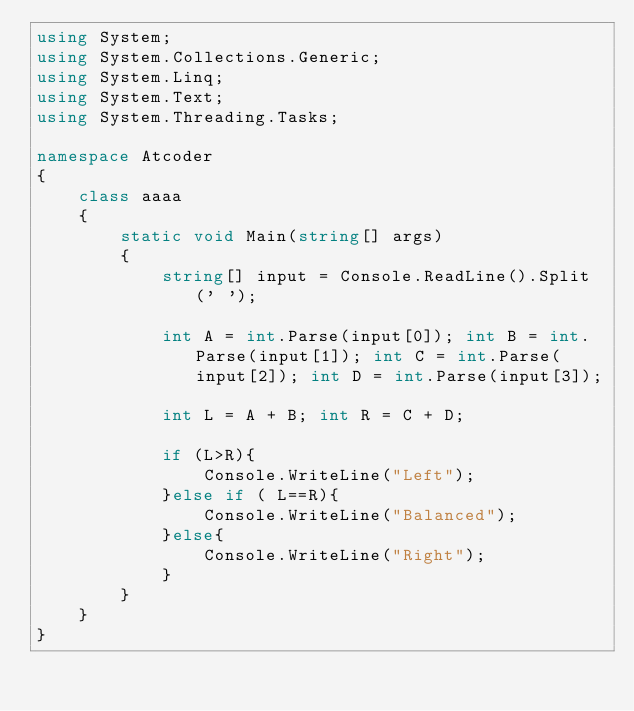Convert code to text. <code><loc_0><loc_0><loc_500><loc_500><_C#_>using System;
using System.Collections.Generic;
using System.Linq;
using System.Text;
using System.Threading.Tasks;
 
namespace Atcoder
{
    class aaaa
    {
        static void Main(string[] args)
        {
            string[] input = Console.ReadLine().Split(' ');

            int A = int.Parse(input[0]); int B = int.Parse(input[1]); int C = int.Parse(input[2]); int D = int.Parse(input[3]); 
        
            int L = A + B; int R = C + D;

            if (L>R){
                Console.WriteLine("Left");
            }else if ( L==R){
                Console.WriteLine("Balanced");
            }else{
                Console.WriteLine("Right");
            }
        }
    }
}</code> 